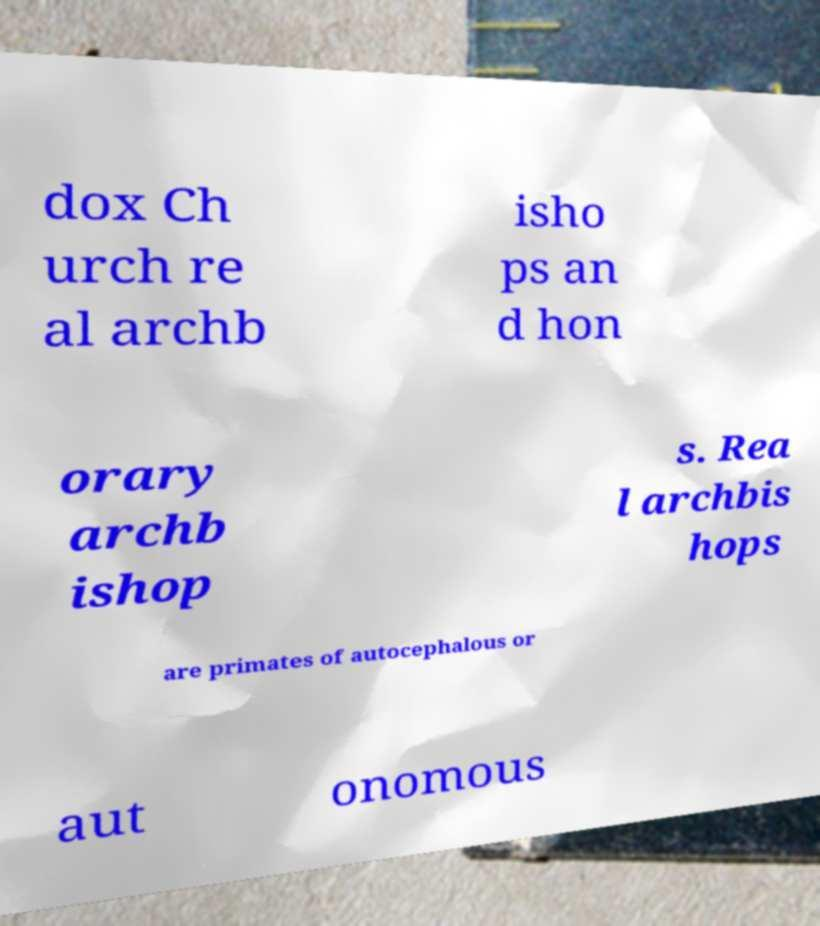Please identify and transcribe the text found in this image. dox Ch urch re al archb isho ps an d hon orary archb ishop s. Rea l archbis hops are primates of autocephalous or aut onomous 